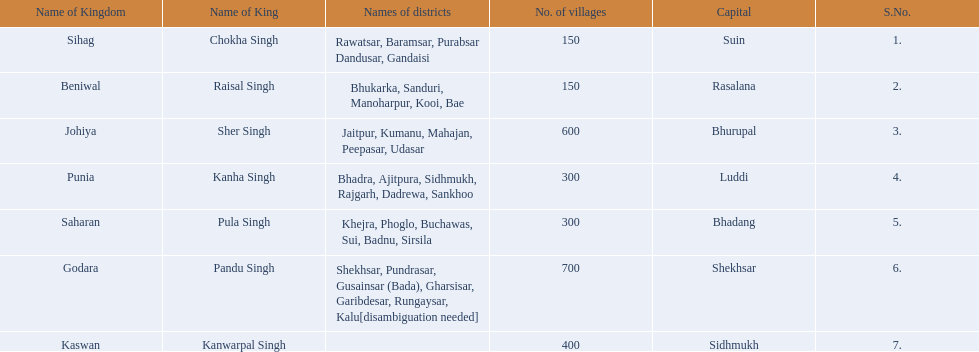What are all of the kingdoms? Sihag, Beniwal, Johiya, Punia, Saharan, Godara, Kaswan. How many villages do they contain? 150, 150, 600, 300, 300, 700, 400. How many are in godara? 700. Which kingdom comes next in highest amount of villages? Johiya. 